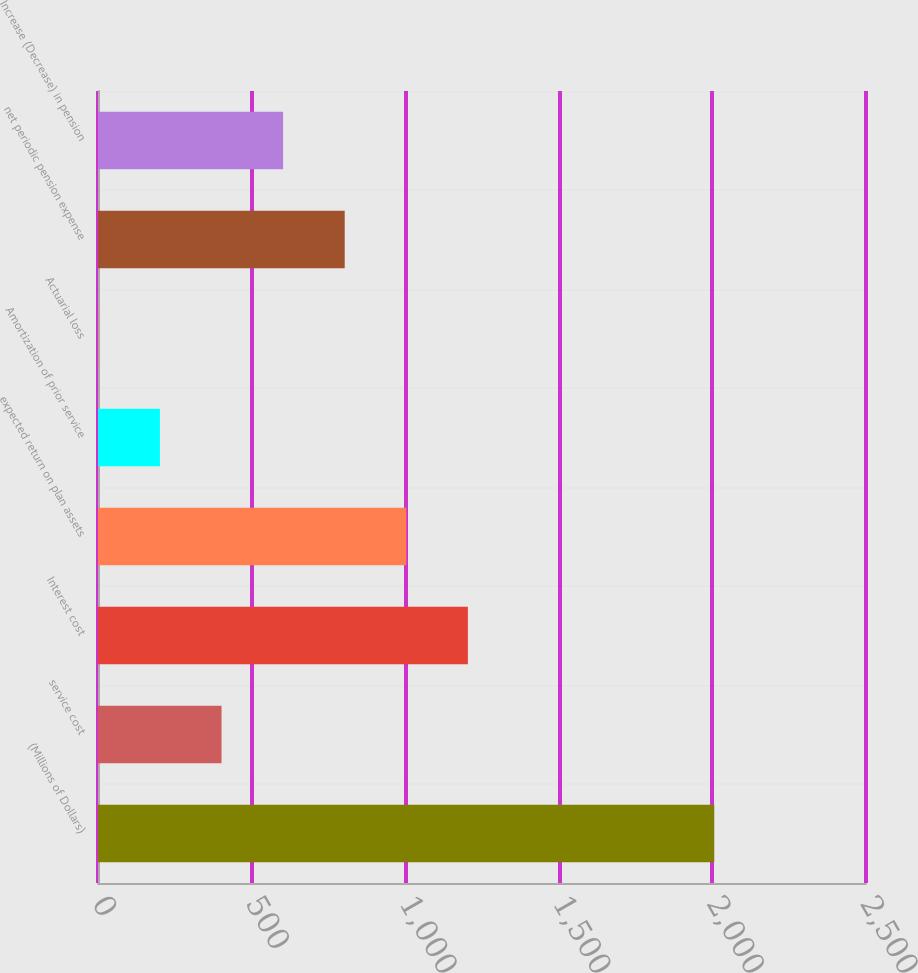<chart> <loc_0><loc_0><loc_500><loc_500><bar_chart><fcel>(Millions of Dollars)<fcel>service cost<fcel>Interest cost<fcel>expected return on plan assets<fcel>Amortization of prior service<fcel>Actuarial loss<fcel>net periodic pension expense<fcel>Increase (Decrease) in pension<nl><fcel>2006<fcel>402.08<fcel>1204.04<fcel>1003.55<fcel>201.59<fcel>1.1<fcel>803.06<fcel>602.57<nl></chart> 